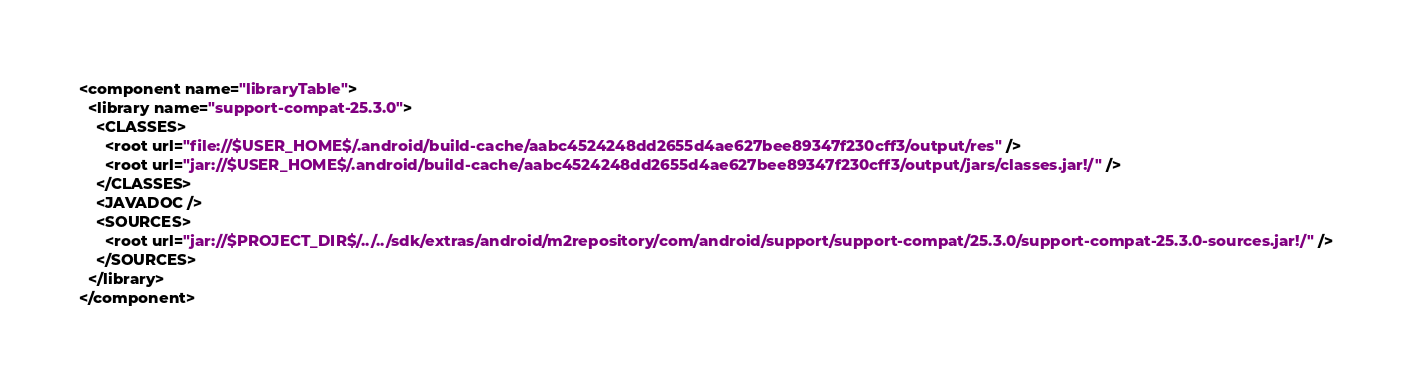<code> <loc_0><loc_0><loc_500><loc_500><_XML_><component name="libraryTable">
  <library name="support-compat-25.3.0">
    <CLASSES>
      <root url="file://$USER_HOME$/.android/build-cache/aabc4524248dd2655d4ae627bee89347f230cff3/output/res" />
      <root url="jar://$USER_HOME$/.android/build-cache/aabc4524248dd2655d4ae627bee89347f230cff3/output/jars/classes.jar!/" />
    </CLASSES>
    <JAVADOC />
    <SOURCES>
      <root url="jar://$PROJECT_DIR$/../../sdk/extras/android/m2repository/com/android/support/support-compat/25.3.0/support-compat-25.3.0-sources.jar!/" />
    </SOURCES>
  </library>
</component></code> 